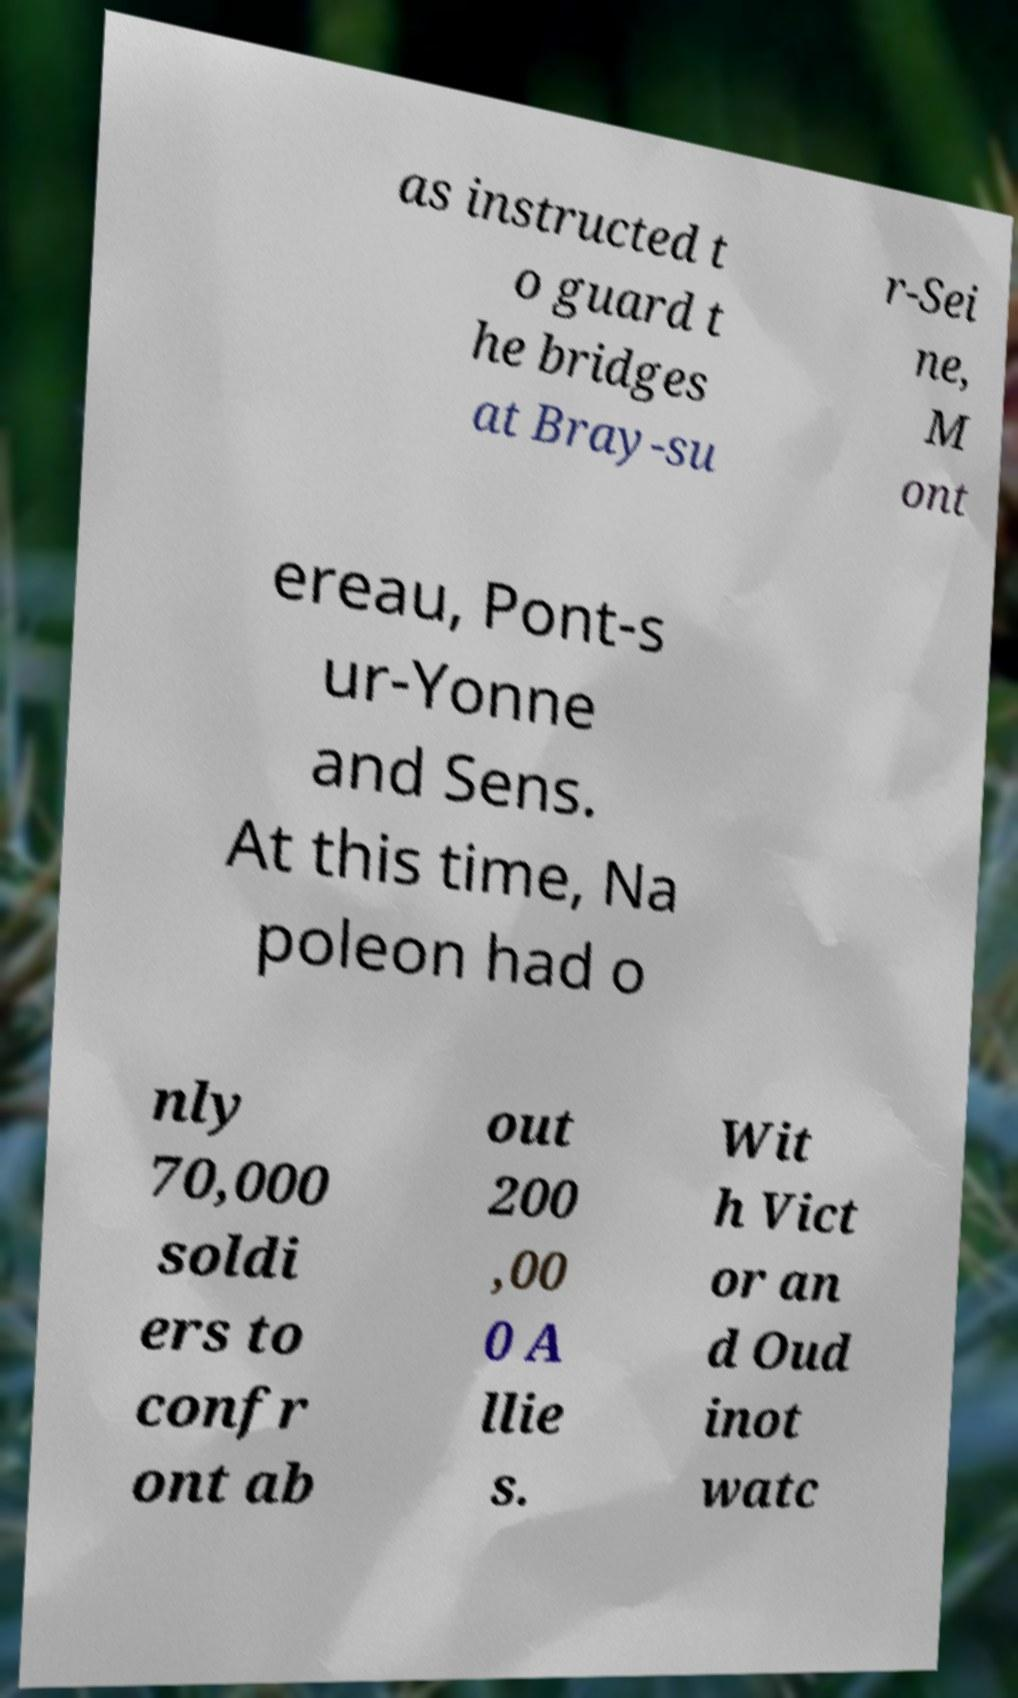What messages or text are displayed in this image? I need them in a readable, typed format. as instructed t o guard t he bridges at Bray-su r-Sei ne, M ont ereau, Pont-s ur-Yonne and Sens. At this time, Na poleon had o nly 70,000 soldi ers to confr ont ab out 200 ,00 0 A llie s. Wit h Vict or an d Oud inot watc 